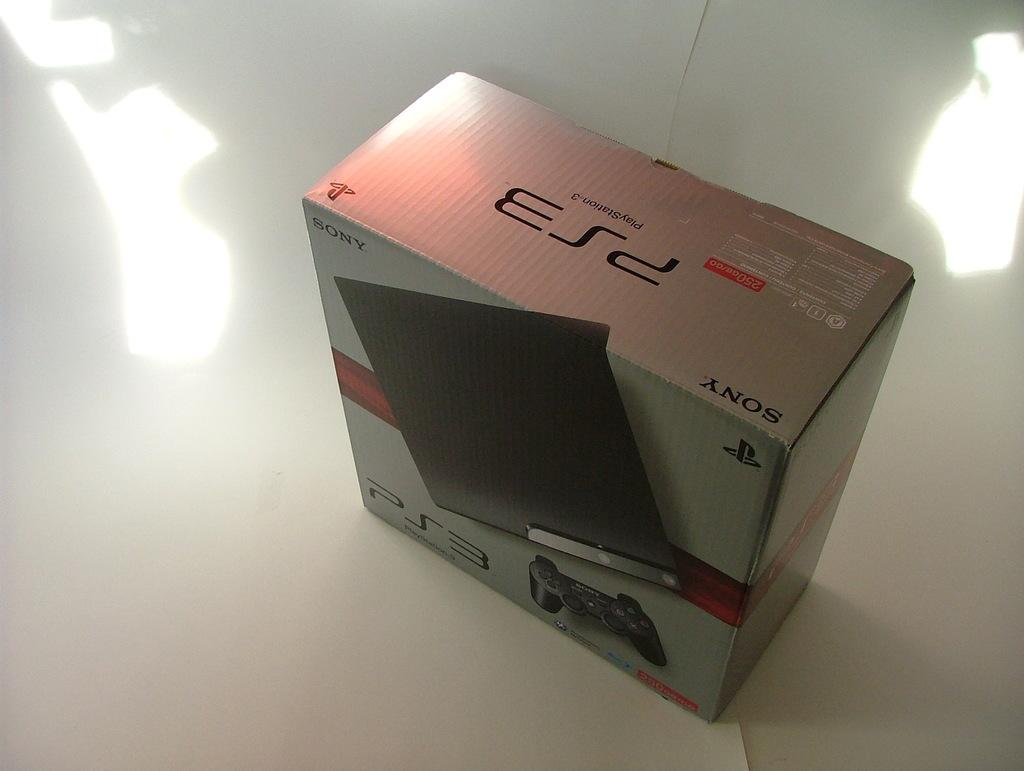Provide a one-sentence caption for the provided image. a PS3 in the box on a white surface. 